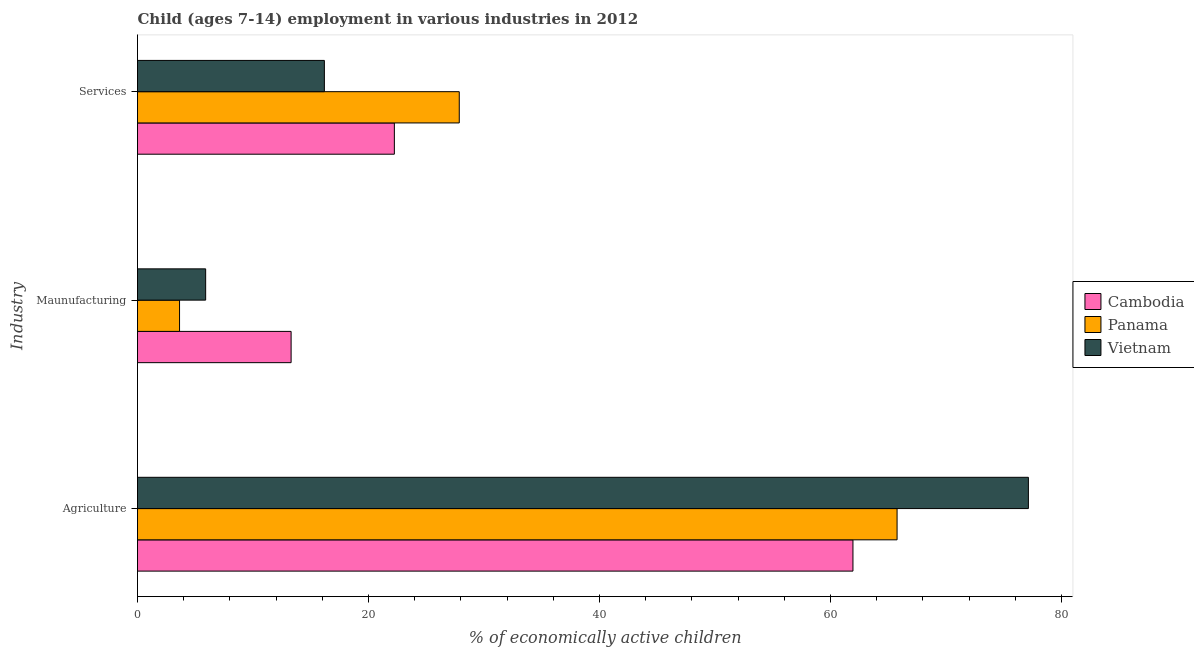Are the number of bars on each tick of the Y-axis equal?
Offer a terse response. Yes. What is the label of the 1st group of bars from the top?
Provide a succinct answer. Services. Across all countries, what is the maximum percentage of economically active children in services?
Provide a short and direct response. 27.86. Across all countries, what is the minimum percentage of economically active children in services?
Your answer should be very brief. 16.18. In which country was the percentage of economically active children in services maximum?
Offer a terse response. Panama. In which country was the percentage of economically active children in agriculture minimum?
Your response must be concise. Cambodia. What is the total percentage of economically active children in services in the graph?
Offer a very short reply. 66.28. What is the difference between the percentage of economically active children in agriculture in Vietnam and that in Panama?
Your answer should be very brief. 11.37. What is the difference between the percentage of economically active children in manufacturing in Cambodia and the percentage of economically active children in agriculture in Panama?
Your answer should be compact. -52.47. What is the average percentage of economically active children in manufacturing per country?
Offer a terse response. 7.61. What is the difference between the percentage of economically active children in manufacturing and percentage of economically active children in agriculture in Panama?
Provide a succinct answer. -62.13. In how many countries, is the percentage of economically active children in manufacturing greater than 76 %?
Your response must be concise. 0. What is the ratio of the percentage of economically active children in manufacturing in Vietnam to that in Cambodia?
Make the answer very short. 0.44. What is the difference between the highest and the lowest percentage of economically active children in services?
Ensure brevity in your answer.  11.68. What does the 3rd bar from the top in Maunufacturing represents?
Provide a succinct answer. Cambodia. What does the 2nd bar from the bottom in Services represents?
Offer a terse response. Panama. Is it the case that in every country, the sum of the percentage of economically active children in agriculture and percentage of economically active children in manufacturing is greater than the percentage of economically active children in services?
Keep it short and to the point. Yes. Are all the bars in the graph horizontal?
Provide a succinct answer. Yes. How many countries are there in the graph?
Offer a terse response. 3. Are the values on the major ticks of X-axis written in scientific E-notation?
Give a very brief answer. No. Does the graph contain any zero values?
Your answer should be very brief. No. Where does the legend appear in the graph?
Provide a succinct answer. Center right. How are the legend labels stacked?
Provide a short and direct response. Vertical. What is the title of the graph?
Provide a succinct answer. Child (ages 7-14) employment in various industries in 2012. Does "Eritrea" appear as one of the legend labels in the graph?
Provide a short and direct response. No. What is the label or title of the X-axis?
Provide a short and direct response. % of economically active children. What is the label or title of the Y-axis?
Give a very brief answer. Industry. What is the % of economically active children in Cambodia in Agriculture?
Give a very brief answer. 61.95. What is the % of economically active children of Panama in Agriculture?
Keep it short and to the point. 65.77. What is the % of economically active children of Vietnam in Agriculture?
Make the answer very short. 77.14. What is the % of economically active children of Panama in Maunufacturing?
Provide a short and direct response. 3.64. What is the % of economically active children of Cambodia in Services?
Provide a short and direct response. 22.24. What is the % of economically active children in Panama in Services?
Keep it short and to the point. 27.86. What is the % of economically active children of Vietnam in Services?
Give a very brief answer. 16.18. Across all Industry, what is the maximum % of economically active children of Cambodia?
Give a very brief answer. 61.95. Across all Industry, what is the maximum % of economically active children in Panama?
Give a very brief answer. 65.77. Across all Industry, what is the maximum % of economically active children of Vietnam?
Your answer should be very brief. 77.14. Across all Industry, what is the minimum % of economically active children in Panama?
Make the answer very short. 3.64. What is the total % of economically active children in Cambodia in the graph?
Offer a very short reply. 97.49. What is the total % of economically active children in Panama in the graph?
Give a very brief answer. 97.27. What is the total % of economically active children of Vietnam in the graph?
Give a very brief answer. 99.22. What is the difference between the % of economically active children of Cambodia in Agriculture and that in Maunufacturing?
Give a very brief answer. 48.65. What is the difference between the % of economically active children of Panama in Agriculture and that in Maunufacturing?
Provide a short and direct response. 62.13. What is the difference between the % of economically active children in Vietnam in Agriculture and that in Maunufacturing?
Provide a succinct answer. 71.24. What is the difference between the % of economically active children in Cambodia in Agriculture and that in Services?
Your answer should be very brief. 39.71. What is the difference between the % of economically active children in Panama in Agriculture and that in Services?
Offer a terse response. 37.91. What is the difference between the % of economically active children of Vietnam in Agriculture and that in Services?
Offer a terse response. 60.96. What is the difference between the % of economically active children in Cambodia in Maunufacturing and that in Services?
Your answer should be very brief. -8.94. What is the difference between the % of economically active children in Panama in Maunufacturing and that in Services?
Your response must be concise. -24.22. What is the difference between the % of economically active children of Vietnam in Maunufacturing and that in Services?
Make the answer very short. -10.28. What is the difference between the % of economically active children of Cambodia in Agriculture and the % of economically active children of Panama in Maunufacturing?
Provide a short and direct response. 58.31. What is the difference between the % of economically active children in Cambodia in Agriculture and the % of economically active children in Vietnam in Maunufacturing?
Keep it short and to the point. 56.05. What is the difference between the % of economically active children of Panama in Agriculture and the % of economically active children of Vietnam in Maunufacturing?
Provide a succinct answer. 59.87. What is the difference between the % of economically active children of Cambodia in Agriculture and the % of economically active children of Panama in Services?
Your response must be concise. 34.09. What is the difference between the % of economically active children in Cambodia in Agriculture and the % of economically active children in Vietnam in Services?
Offer a very short reply. 45.77. What is the difference between the % of economically active children in Panama in Agriculture and the % of economically active children in Vietnam in Services?
Keep it short and to the point. 49.59. What is the difference between the % of economically active children in Cambodia in Maunufacturing and the % of economically active children in Panama in Services?
Your answer should be compact. -14.56. What is the difference between the % of economically active children of Cambodia in Maunufacturing and the % of economically active children of Vietnam in Services?
Provide a succinct answer. -2.88. What is the difference between the % of economically active children of Panama in Maunufacturing and the % of economically active children of Vietnam in Services?
Give a very brief answer. -12.54. What is the average % of economically active children in Cambodia per Industry?
Offer a terse response. 32.5. What is the average % of economically active children in Panama per Industry?
Make the answer very short. 32.42. What is the average % of economically active children in Vietnam per Industry?
Keep it short and to the point. 33.07. What is the difference between the % of economically active children of Cambodia and % of economically active children of Panama in Agriculture?
Provide a short and direct response. -3.82. What is the difference between the % of economically active children in Cambodia and % of economically active children in Vietnam in Agriculture?
Offer a terse response. -15.19. What is the difference between the % of economically active children in Panama and % of economically active children in Vietnam in Agriculture?
Your answer should be compact. -11.37. What is the difference between the % of economically active children of Cambodia and % of economically active children of Panama in Maunufacturing?
Offer a terse response. 9.66. What is the difference between the % of economically active children in Panama and % of economically active children in Vietnam in Maunufacturing?
Your response must be concise. -2.26. What is the difference between the % of economically active children in Cambodia and % of economically active children in Panama in Services?
Provide a succinct answer. -5.62. What is the difference between the % of economically active children in Cambodia and % of economically active children in Vietnam in Services?
Offer a very short reply. 6.06. What is the difference between the % of economically active children of Panama and % of economically active children of Vietnam in Services?
Your answer should be very brief. 11.68. What is the ratio of the % of economically active children in Cambodia in Agriculture to that in Maunufacturing?
Make the answer very short. 4.66. What is the ratio of the % of economically active children of Panama in Agriculture to that in Maunufacturing?
Keep it short and to the point. 18.07. What is the ratio of the % of economically active children in Vietnam in Agriculture to that in Maunufacturing?
Offer a very short reply. 13.07. What is the ratio of the % of economically active children in Cambodia in Agriculture to that in Services?
Your answer should be compact. 2.79. What is the ratio of the % of economically active children in Panama in Agriculture to that in Services?
Make the answer very short. 2.36. What is the ratio of the % of economically active children of Vietnam in Agriculture to that in Services?
Provide a short and direct response. 4.77. What is the ratio of the % of economically active children of Cambodia in Maunufacturing to that in Services?
Ensure brevity in your answer.  0.6. What is the ratio of the % of economically active children in Panama in Maunufacturing to that in Services?
Give a very brief answer. 0.13. What is the ratio of the % of economically active children in Vietnam in Maunufacturing to that in Services?
Make the answer very short. 0.36. What is the difference between the highest and the second highest % of economically active children in Cambodia?
Your answer should be very brief. 39.71. What is the difference between the highest and the second highest % of economically active children in Panama?
Offer a very short reply. 37.91. What is the difference between the highest and the second highest % of economically active children in Vietnam?
Make the answer very short. 60.96. What is the difference between the highest and the lowest % of economically active children of Cambodia?
Provide a succinct answer. 48.65. What is the difference between the highest and the lowest % of economically active children in Panama?
Your answer should be compact. 62.13. What is the difference between the highest and the lowest % of economically active children in Vietnam?
Keep it short and to the point. 71.24. 